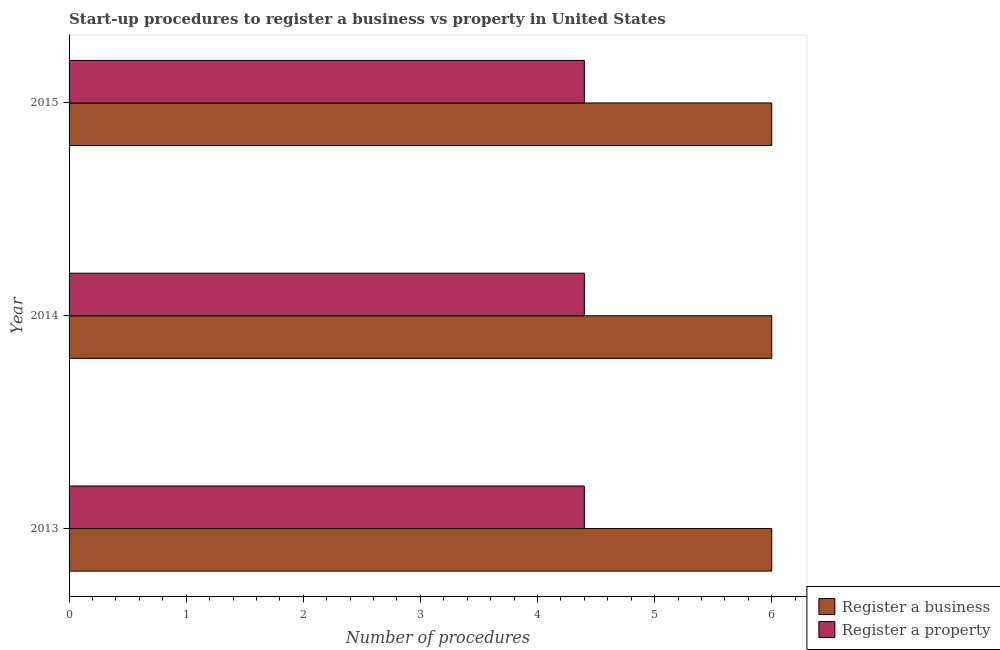How many groups of bars are there?
Make the answer very short. 3. Are the number of bars per tick equal to the number of legend labels?
Give a very brief answer. Yes. Are the number of bars on each tick of the Y-axis equal?
Offer a terse response. Yes. How many bars are there on the 2nd tick from the bottom?
Offer a very short reply. 2. What is the label of the 1st group of bars from the top?
Make the answer very short. 2015. In how many cases, is the number of bars for a given year not equal to the number of legend labels?
Offer a very short reply. 0. What is the number of procedures to register a property in 2015?
Provide a short and direct response. 4.4. Across all years, what is the maximum number of procedures to register a property?
Provide a succinct answer. 4.4. In which year was the number of procedures to register a property maximum?
Give a very brief answer. 2013. What is the total number of procedures to register a property in the graph?
Provide a short and direct response. 13.2. What is the difference between the number of procedures to register a business in 2014 and that in 2015?
Ensure brevity in your answer.  0. What is the difference between the number of procedures to register a business in 2013 and the number of procedures to register a property in 2014?
Offer a very short reply. 1.6. What is the ratio of the number of procedures to register a property in 2013 to that in 2015?
Your response must be concise. 1. Is the number of procedures to register a business in 2013 less than that in 2015?
Your answer should be compact. No. What is the difference between the highest and the second highest number of procedures to register a property?
Offer a very short reply. 0. What does the 2nd bar from the top in 2015 represents?
Your answer should be compact. Register a business. What does the 1st bar from the bottom in 2014 represents?
Offer a terse response. Register a business. How many bars are there?
Offer a very short reply. 6. How many years are there in the graph?
Give a very brief answer. 3. Are the values on the major ticks of X-axis written in scientific E-notation?
Your response must be concise. No. What is the title of the graph?
Ensure brevity in your answer.  Start-up procedures to register a business vs property in United States. Does "Current US$" appear as one of the legend labels in the graph?
Keep it short and to the point. No. What is the label or title of the X-axis?
Provide a short and direct response. Number of procedures. What is the label or title of the Y-axis?
Offer a terse response. Year. What is the Number of procedures in Register a property in 2014?
Provide a short and direct response. 4.4. What is the Number of procedures in Register a business in 2015?
Make the answer very short. 6. What is the Number of procedures in Register a property in 2015?
Keep it short and to the point. 4.4. Across all years, what is the maximum Number of procedures in Register a business?
Make the answer very short. 6. Across all years, what is the minimum Number of procedures of Register a business?
Your answer should be compact. 6. What is the difference between the Number of procedures in Register a business in 2013 and that in 2014?
Provide a succinct answer. 0. What is the difference between the Number of procedures of Register a business in 2013 and that in 2015?
Offer a terse response. 0. What is the difference between the Number of procedures of Register a property in 2013 and that in 2015?
Ensure brevity in your answer.  0. What is the difference between the Number of procedures of Register a business in 2013 and the Number of procedures of Register a property in 2014?
Your answer should be very brief. 1.6. What is the difference between the Number of procedures of Register a business in 2014 and the Number of procedures of Register a property in 2015?
Provide a short and direct response. 1.6. What is the average Number of procedures in Register a business per year?
Your answer should be very brief. 6. In the year 2013, what is the difference between the Number of procedures of Register a business and Number of procedures of Register a property?
Your answer should be compact. 1.6. In the year 2014, what is the difference between the Number of procedures of Register a business and Number of procedures of Register a property?
Provide a short and direct response. 1.6. In the year 2015, what is the difference between the Number of procedures in Register a business and Number of procedures in Register a property?
Provide a succinct answer. 1.6. What is the ratio of the Number of procedures in Register a business in 2013 to that in 2014?
Provide a succinct answer. 1. What is the ratio of the Number of procedures of Register a property in 2013 to that in 2014?
Keep it short and to the point. 1. What is the ratio of the Number of procedures in Register a business in 2013 to that in 2015?
Keep it short and to the point. 1. What is the ratio of the Number of procedures in Register a business in 2014 to that in 2015?
Make the answer very short. 1. What is the difference between the highest and the lowest Number of procedures of Register a business?
Offer a terse response. 0. 